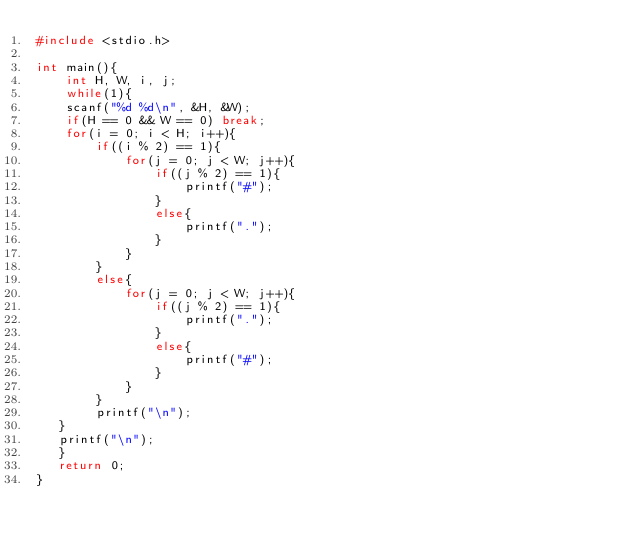<code> <loc_0><loc_0><loc_500><loc_500><_C++_>#include <stdio.h>

int main(){
    int H, W, i, j;
    while(1){
    scanf("%d %d\n", &H, &W);
    if(H == 0 && W == 0) break;
    for(i = 0; i < H; i++){
        if((i % 2) == 1){
            for(j = 0; j < W; j++){
                if((j % 2) == 1){
                    printf("#");
                }
                else{
                    printf(".");
                }
            }
        }
        else{
            for(j = 0; j < W; j++){
                if((j % 2) == 1){
                    printf(".");
                }
                else{
                    printf("#");
                }
            }
        }
        printf("\n");
   }
   printf("\n");
   }
   return 0;
}</code> 